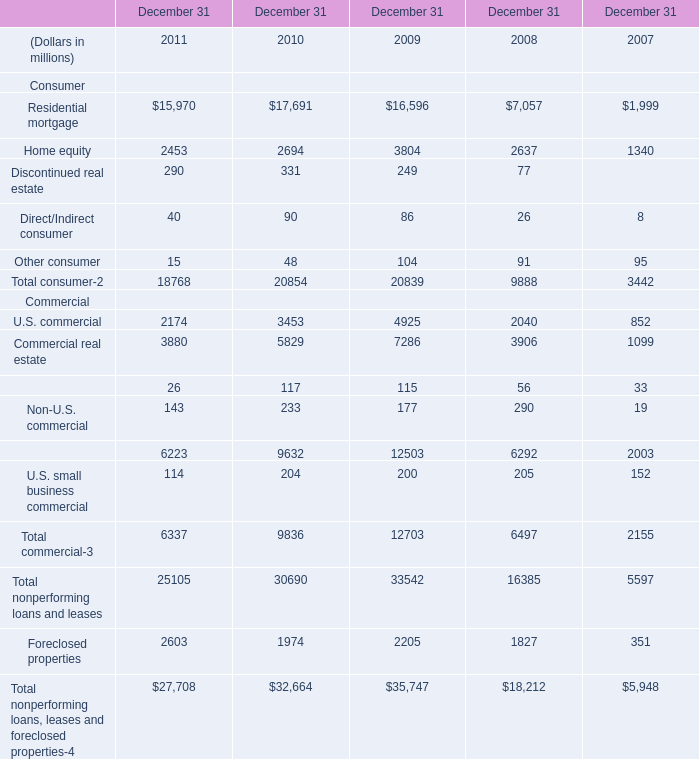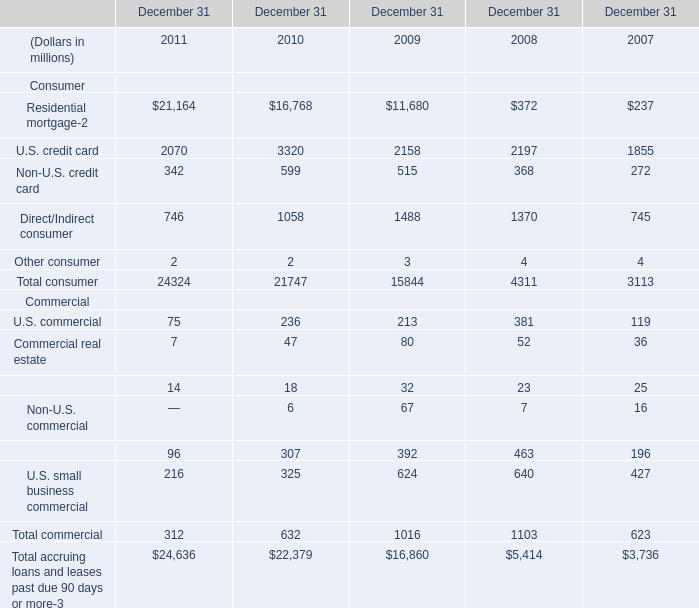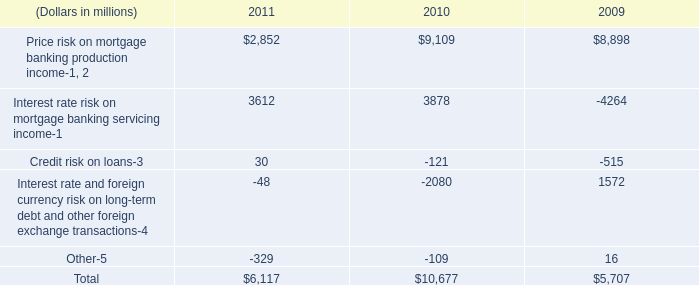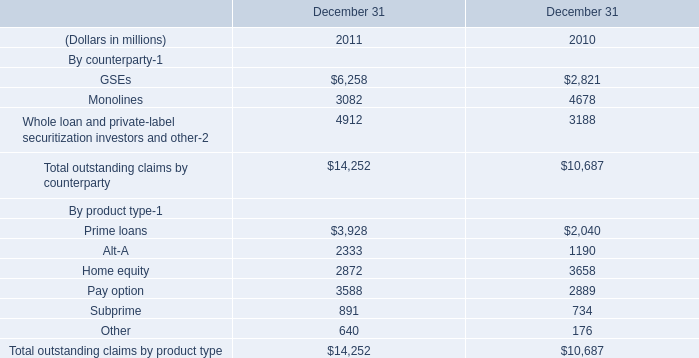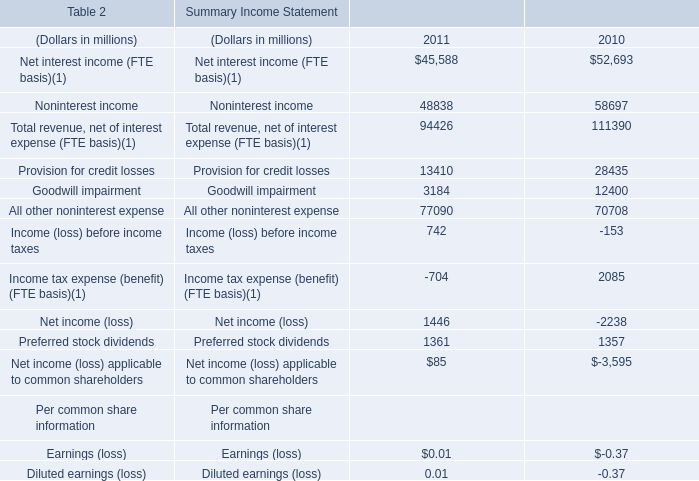Does U.S. credit card keeps increasing each year between 2011 and 2010? 
Answer: no. 